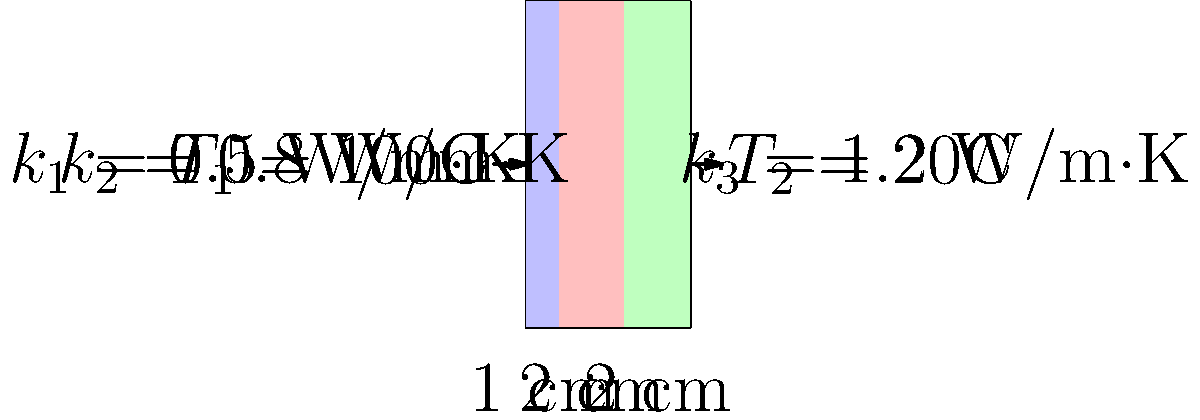In the dreamscape of thermal flow, a wall of three layers stands,
Each with its own conductivity, like stanzas in poetic lands.
From left to right, the thicknesses are 1, 2, and 2 cm,
With temperatures at either end, a thermal poem to comprehend.
If the heat transfer rate is 2000 W/m², what area does this wall command? To solve this poetic puzzle of heat transfer, let's follow these steps:

1) First, recall the formula for heat transfer rate through a composite wall:

   $$q = \frac{T_1 - T_2}{\sum\frac{L_i}{k_i A}}$$

   where $q$ is the heat transfer rate, $T_1$ and $T_2$ are the temperatures, $L_i$ are the layer thicknesses, $k_i$ are the thermal conductivities, and $A$ is the area.

2) We're given $q = 2000$ W/m², $T_1 = 100°$C, and $T_2 = 20°$C. Let's substitute these:

   $$2000 = \frac{100 - 20}{\sum\frac{L_i}{k_i A}}$$

3) Now, let's calculate $\sum\frac{L_i}{k_i A}$:

   $$\sum\frac{L_i}{k_i A} = \frac{0.01}{0.5A} + \frac{0.02}{0.8A} + \frac{0.02}{1.2A}$$

4) Simplify:

   $$\sum\frac{L_i}{k_i A} = \frac{0.02}{A} + \frac{0.025}{A} + \frac{0.0167}{A} = \frac{0.0617}{A}$$

5) Substitute this back into our equation:

   $$2000 = \frac{80}{\frac{0.0617}{A}}$$

6) Solve for $A$:

   $$A = \frac{80}{2000 * 0.0617} = 0.0647 \text{ m}^2$$

Thus, the wall has an area of 0.0647 m².
Answer: 0.0647 m² 